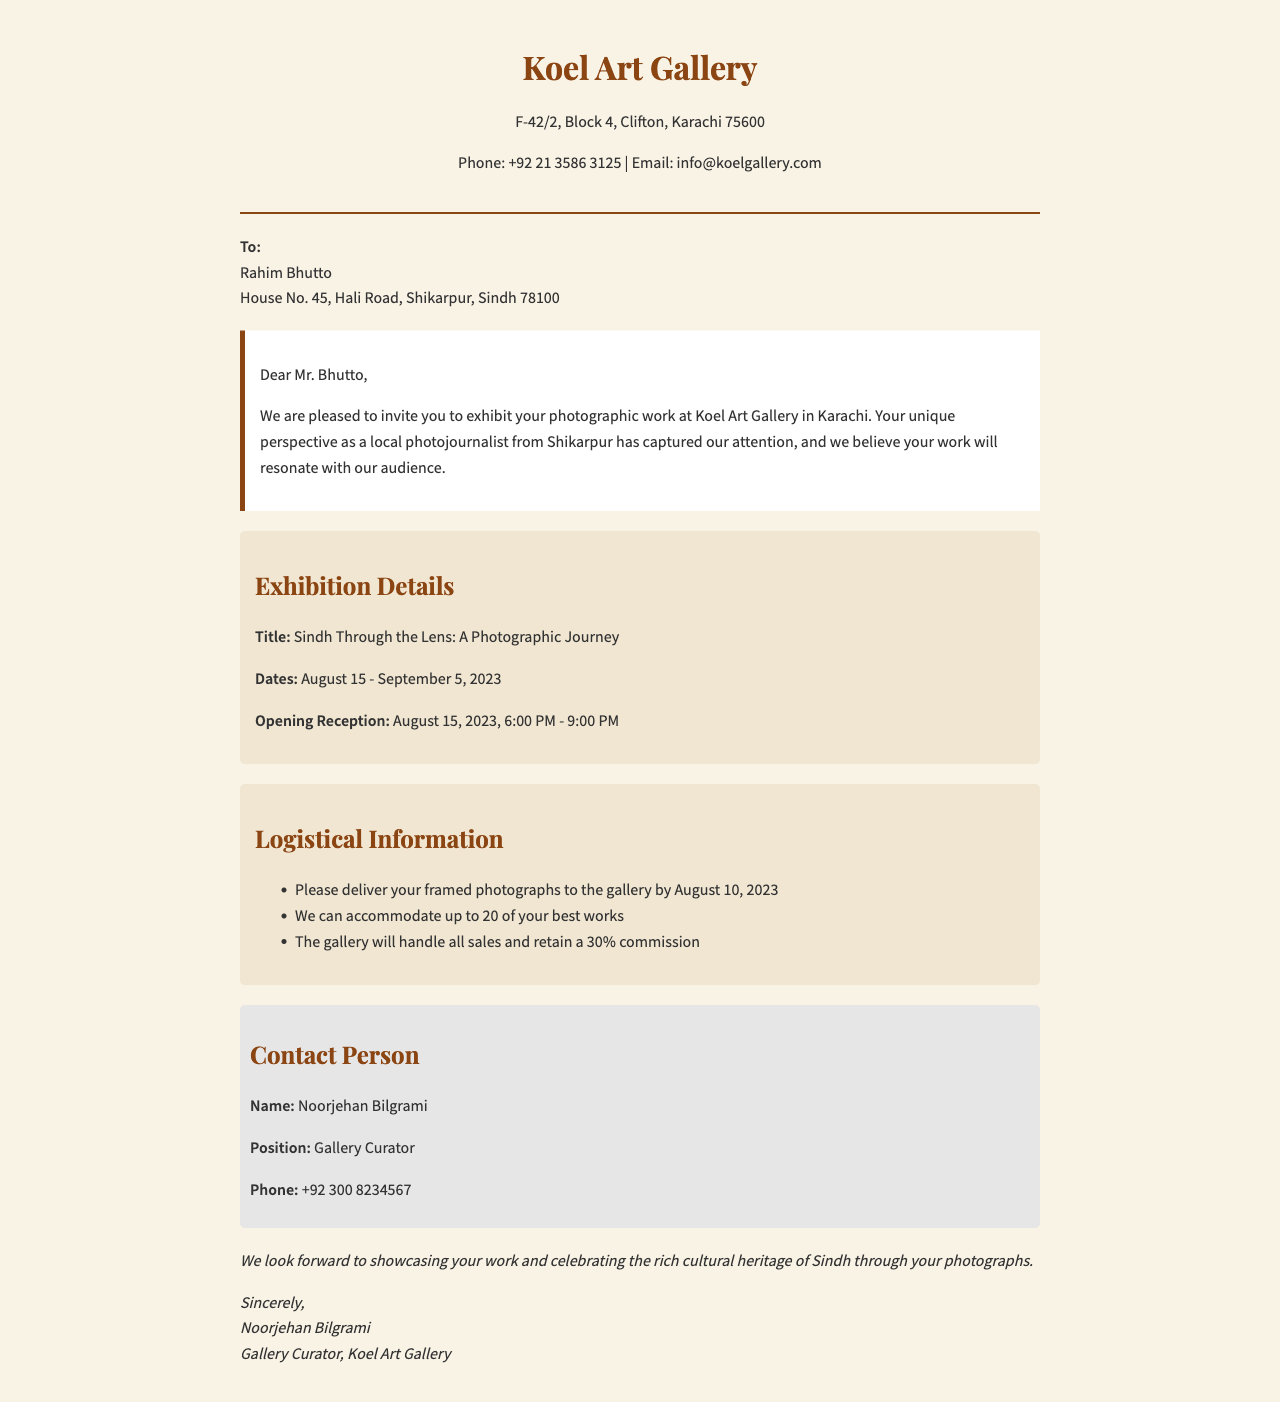what is the title of the exhibition? The title of the exhibition is mentioned in the exhibition details section of the document.
Answer: Sindh Through the Lens: A Photographic Journey what are the exhibition dates? The exhibition dates are specified under the exhibition details section.
Answer: August 15 - September 5, 2023 who is the contact person for the exhibition? The document identifies a specific individual responsible for communication regarding the exhibition.
Answer: Noorjehan Bilgrami when is the opening reception scheduled? The opening reception date and time are provided in the exhibition details section.
Answer: August 15, 2023, 6:00 PM - 9:00 PM how many photographs can be accommodated in the exhibition? The logistical information section specifies the number of photographs that can be displayed.
Answer: 20 what is the commission percentage for sales? The percentage that the gallery retains from sales is mentioned in the logistical information.
Answer: 30% what is the delivery deadline for the photographs? The document clearly states the date by which the photographs should be delivered to the gallery.
Answer: August 10, 2023 where is Koel Art Gallery located? The address of the gallery is provided at the beginning of the document.
Answer: F-42/2, Block 4, Clifton, Karachi 75600 who is invited to exhibit photographs? The document addresses the invitation specifically to an individual with a specific role.
Answer: Rahim Bhutto 